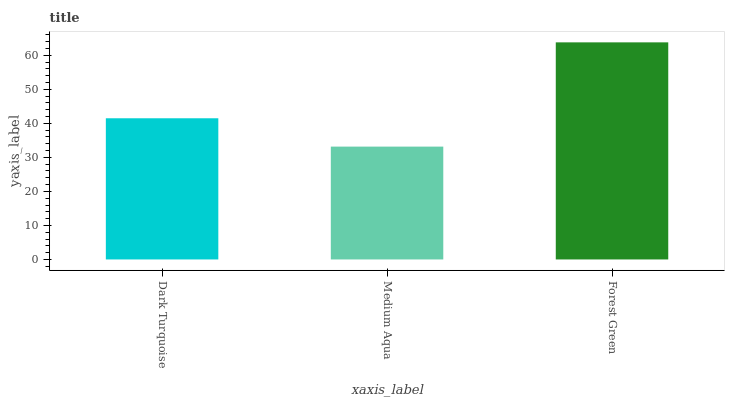Is Medium Aqua the minimum?
Answer yes or no. Yes. Is Forest Green the maximum?
Answer yes or no. Yes. Is Forest Green the minimum?
Answer yes or no. No. Is Medium Aqua the maximum?
Answer yes or no. No. Is Forest Green greater than Medium Aqua?
Answer yes or no. Yes. Is Medium Aqua less than Forest Green?
Answer yes or no. Yes. Is Medium Aqua greater than Forest Green?
Answer yes or no. No. Is Forest Green less than Medium Aqua?
Answer yes or no. No. Is Dark Turquoise the high median?
Answer yes or no. Yes. Is Dark Turquoise the low median?
Answer yes or no. Yes. Is Forest Green the high median?
Answer yes or no. No. Is Medium Aqua the low median?
Answer yes or no. No. 